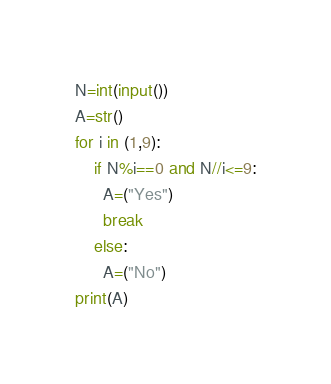<code> <loc_0><loc_0><loc_500><loc_500><_Python_>N=int(input())
A=str()
for i in (1,9):
    if N%i==0 and N//i<=9:
      A=("Yes")
      break
    else:
      A=("No")
print(A)</code> 